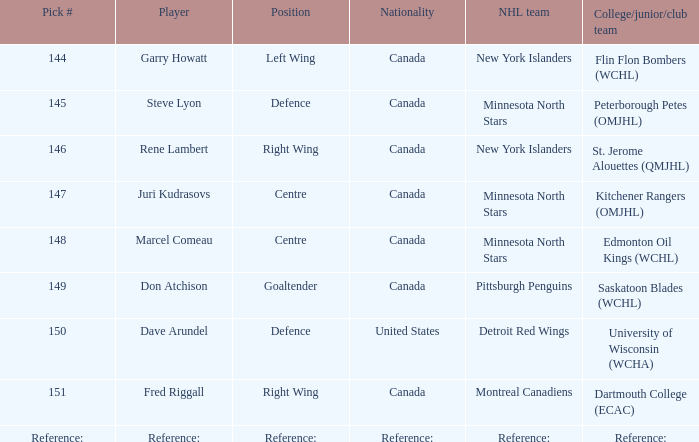Which player(s) was picked by the pittsburgh penguins? Don Atchison. 